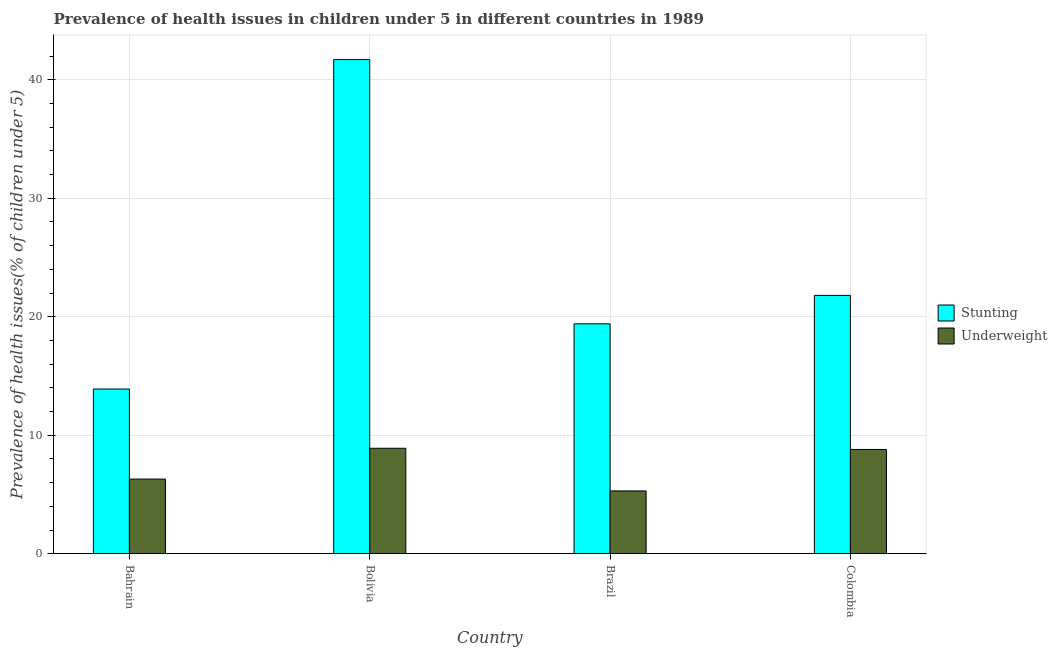What is the percentage of stunted children in Bolivia?
Provide a short and direct response. 41.7. Across all countries, what is the maximum percentage of underweight children?
Make the answer very short. 8.9. Across all countries, what is the minimum percentage of underweight children?
Give a very brief answer. 5.3. In which country was the percentage of stunted children minimum?
Your answer should be compact. Bahrain. What is the total percentage of stunted children in the graph?
Provide a succinct answer. 96.8. What is the difference between the percentage of underweight children in Bolivia and that in Brazil?
Your response must be concise. 3.6. What is the difference between the percentage of stunted children in Bolivia and the percentage of underweight children in Bahrain?
Provide a short and direct response. 35.4. What is the average percentage of underweight children per country?
Make the answer very short. 7.33. What is the difference between the percentage of stunted children and percentage of underweight children in Brazil?
Give a very brief answer. 14.1. In how many countries, is the percentage of stunted children greater than 16 %?
Provide a short and direct response. 3. What is the ratio of the percentage of stunted children in Bahrain to that in Bolivia?
Make the answer very short. 0.33. Is the percentage of underweight children in Bahrain less than that in Colombia?
Your response must be concise. Yes. Is the difference between the percentage of underweight children in Brazil and Colombia greater than the difference between the percentage of stunted children in Brazil and Colombia?
Keep it short and to the point. No. What is the difference between the highest and the second highest percentage of stunted children?
Provide a short and direct response. 19.9. What is the difference between the highest and the lowest percentage of underweight children?
Provide a short and direct response. 3.6. What does the 2nd bar from the left in Bahrain represents?
Provide a succinct answer. Underweight. What does the 2nd bar from the right in Colombia represents?
Offer a terse response. Stunting. How many bars are there?
Keep it short and to the point. 8. Are all the bars in the graph horizontal?
Keep it short and to the point. No. Does the graph contain grids?
Offer a terse response. Yes. Where does the legend appear in the graph?
Provide a short and direct response. Center right. How many legend labels are there?
Provide a succinct answer. 2. How are the legend labels stacked?
Your answer should be compact. Vertical. What is the title of the graph?
Give a very brief answer. Prevalence of health issues in children under 5 in different countries in 1989. Does "Sanitation services" appear as one of the legend labels in the graph?
Your answer should be compact. No. What is the label or title of the Y-axis?
Your response must be concise. Prevalence of health issues(% of children under 5). What is the Prevalence of health issues(% of children under 5) of Stunting in Bahrain?
Ensure brevity in your answer.  13.9. What is the Prevalence of health issues(% of children under 5) in Underweight in Bahrain?
Provide a short and direct response. 6.3. What is the Prevalence of health issues(% of children under 5) of Stunting in Bolivia?
Keep it short and to the point. 41.7. What is the Prevalence of health issues(% of children under 5) in Underweight in Bolivia?
Keep it short and to the point. 8.9. What is the Prevalence of health issues(% of children under 5) of Stunting in Brazil?
Provide a short and direct response. 19.4. What is the Prevalence of health issues(% of children under 5) in Underweight in Brazil?
Offer a terse response. 5.3. What is the Prevalence of health issues(% of children under 5) of Stunting in Colombia?
Make the answer very short. 21.8. What is the Prevalence of health issues(% of children under 5) in Underweight in Colombia?
Ensure brevity in your answer.  8.8. Across all countries, what is the maximum Prevalence of health issues(% of children under 5) in Stunting?
Offer a terse response. 41.7. Across all countries, what is the maximum Prevalence of health issues(% of children under 5) of Underweight?
Give a very brief answer. 8.9. Across all countries, what is the minimum Prevalence of health issues(% of children under 5) of Stunting?
Offer a terse response. 13.9. Across all countries, what is the minimum Prevalence of health issues(% of children under 5) of Underweight?
Your response must be concise. 5.3. What is the total Prevalence of health issues(% of children under 5) of Stunting in the graph?
Your response must be concise. 96.8. What is the total Prevalence of health issues(% of children under 5) in Underweight in the graph?
Your answer should be compact. 29.3. What is the difference between the Prevalence of health issues(% of children under 5) of Stunting in Bahrain and that in Bolivia?
Keep it short and to the point. -27.8. What is the difference between the Prevalence of health issues(% of children under 5) of Underweight in Bahrain and that in Bolivia?
Your answer should be compact. -2.6. What is the difference between the Prevalence of health issues(% of children under 5) of Stunting in Bahrain and that in Colombia?
Ensure brevity in your answer.  -7.9. What is the difference between the Prevalence of health issues(% of children under 5) of Stunting in Bolivia and that in Brazil?
Give a very brief answer. 22.3. What is the difference between the Prevalence of health issues(% of children under 5) in Stunting in Bolivia and that in Colombia?
Provide a short and direct response. 19.9. What is the difference between the Prevalence of health issues(% of children under 5) in Underweight in Bolivia and that in Colombia?
Your answer should be compact. 0.1. What is the difference between the Prevalence of health issues(% of children under 5) in Underweight in Brazil and that in Colombia?
Provide a succinct answer. -3.5. What is the difference between the Prevalence of health issues(% of children under 5) in Stunting in Bahrain and the Prevalence of health issues(% of children under 5) in Underweight in Bolivia?
Your response must be concise. 5. What is the difference between the Prevalence of health issues(% of children under 5) of Stunting in Bahrain and the Prevalence of health issues(% of children under 5) of Underweight in Brazil?
Ensure brevity in your answer.  8.6. What is the difference between the Prevalence of health issues(% of children under 5) in Stunting in Bolivia and the Prevalence of health issues(% of children under 5) in Underweight in Brazil?
Provide a succinct answer. 36.4. What is the difference between the Prevalence of health issues(% of children under 5) in Stunting in Bolivia and the Prevalence of health issues(% of children under 5) in Underweight in Colombia?
Your response must be concise. 32.9. What is the average Prevalence of health issues(% of children under 5) in Stunting per country?
Keep it short and to the point. 24.2. What is the average Prevalence of health issues(% of children under 5) in Underweight per country?
Give a very brief answer. 7.33. What is the difference between the Prevalence of health issues(% of children under 5) in Stunting and Prevalence of health issues(% of children under 5) in Underweight in Bahrain?
Offer a very short reply. 7.6. What is the difference between the Prevalence of health issues(% of children under 5) in Stunting and Prevalence of health issues(% of children under 5) in Underweight in Bolivia?
Keep it short and to the point. 32.8. What is the difference between the Prevalence of health issues(% of children under 5) in Stunting and Prevalence of health issues(% of children under 5) in Underweight in Brazil?
Your response must be concise. 14.1. What is the difference between the Prevalence of health issues(% of children under 5) in Stunting and Prevalence of health issues(% of children under 5) in Underweight in Colombia?
Your answer should be very brief. 13. What is the ratio of the Prevalence of health issues(% of children under 5) of Stunting in Bahrain to that in Bolivia?
Provide a succinct answer. 0.33. What is the ratio of the Prevalence of health issues(% of children under 5) of Underweight in Bahrain to that in Bolivia?
Provide a succinct answer. 0.71. What is the ratio of the Prevalence of health issues(% of children under 5) of Stunting in Bahrain to that in Brazil?
Keep it short and to the point. 0.72. What is the ratio of the Prevalence of health issues(% of children under 5) in Underweight in Bahrain to that in Brazil?
Keep it short and to the point. 1.19. What is the ratio of the Prevalence of health issues(% of children under 5) of Stunting in Bahrain to that in Colombia?
Give a very brief answer. 0.64. What is the ratio of the Prevalence of health issues(% of children under 5) of Underweight in Bahrain to that in Colombia?
Offer a very short reply. 0.72. What is the ratio of the Prevalence of health issues(% of children under 5) of Stunting in Bolivia to that in Brazil?
Give a very brief answer. 2.15. What is the ratio of the Prevalence of health issues(% of children under 5) of Underweight in Bolivia to that in Brazil?
Give a very brief answer. 1.68. What is the ratio of the Prevalence of health issues(% of children under 5) in Stunting in Bolivia to that in Colombia?
Provide a short and direct response. 1.91. What is the ratio of the Prevalence of health issues(% of children under 5) of Underweight in Bolivia to that in Colombia?
Give a very brief answer. 1.01. What is the ratio of the Prevalence of health issues(% of children under 5) in Stunting in Brazil to that in Colombia?
Your answer should be very brief. 0.89. What is the ratio of the Prevalence of health issues(% of children under 5) in Underweight in Brazil to that in Colombia?
Your answer should be very brief. 0.6. What is the difference between the highest and the second highest Prevalence of health issues(% of children under 5) of Underweight?
Make the answer very short. 0.1. What is the difference between the highest and the lowest Prevalence of health issues(% of children under 5) of Stunting?
Your answer should be very brief. 27.8. 